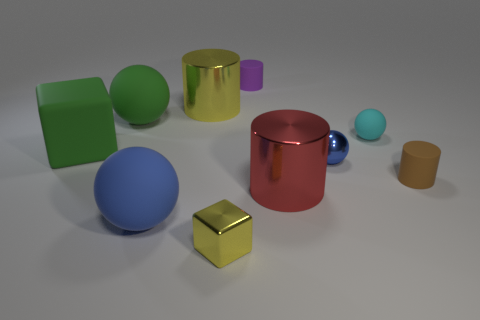Subtract all matte spheres. How many spheres are left? 1 Subtract all brown cylinders. How many cylinders are left? 3 Subtract 1 cylinders. How many cylinders are left? 3 Subtract all yellow blocks. How many purple balls are left? 0 Add 8 small shiny things. How many small shiny things are left? 10 Add 5 red things. How many red things exist? 6 Subtract 1 red cylinders. How many objects are left? 9 Subtract all blocks. How many objects are left? 8 Subtract all cyan cylinders. Subtract all brown balls. How many cylinders are left? 4 Subtract all tiny yellow cylinders. Subtract all small yellow shiny cubes. How many objects are left? 9 